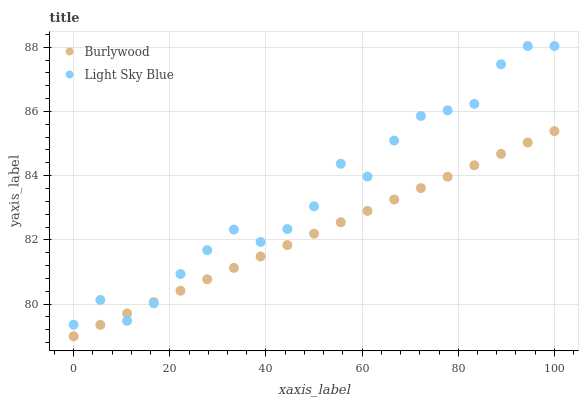Does Burlywood have the minimum area under the curve?
Answer yes or no. Yes. Does Light Sky Blue have the maximum area under the curve?
Answer yes or no. Yes. Does Light Sky Blue have the minimum area under the curve?
Answer yes or no. No. Is Burlywood the smoothest?
Answer yes or no. Yes. Is Light Sky Blue the roughest?
Answer yes or no. Yes. Is Light Sky Blue the smoothest?
Answer yes or no. No. Does Burlywood have the lowest value?
Answer yes or no. Yes. Does Light Sky Blue have the lowest value?
Answer yes or no. No. Does Light Sky Blue have the highest value?
Answer yes or no. Yes. Does Burlywood intersect Light Sky Blue?
Answer yes or no. Yes. Is Burlywood less than Light Sky Blue?
Answer yes or no. No. Is Burlywood greater than Light Sky Blue?
Answer yes or no. No. 